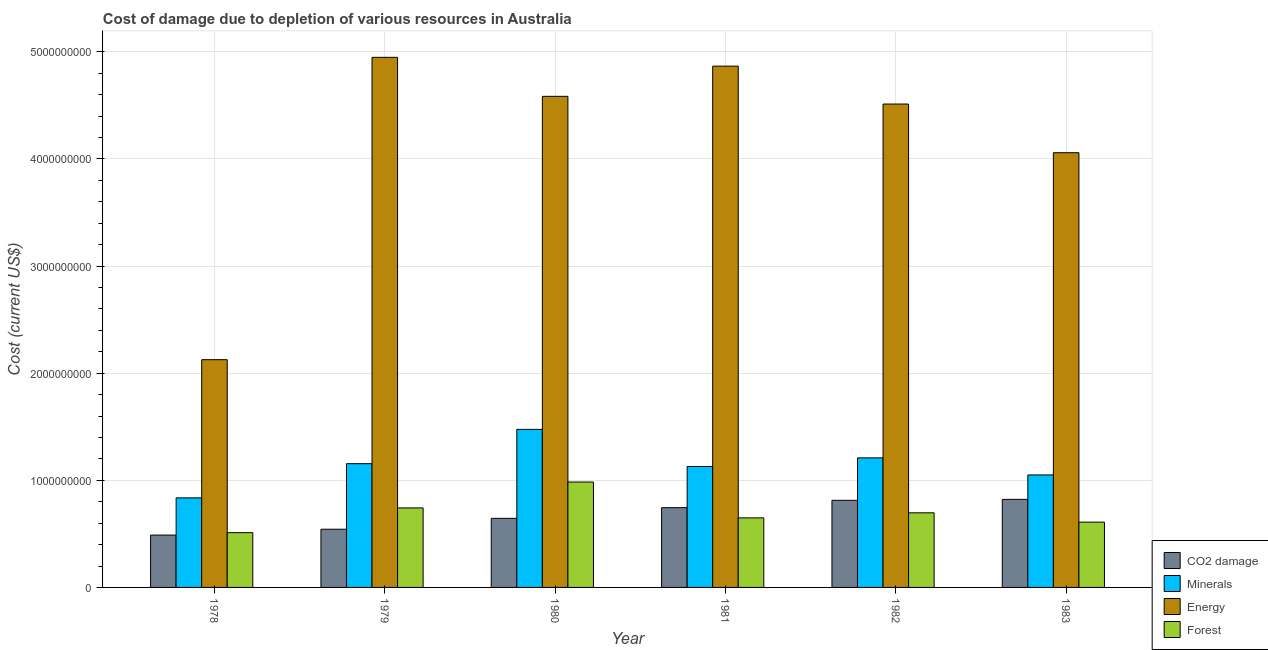How many different coloured bars are there?
Offer a terse response. 4. How many groups of bars are there?
Give a very brief answer. 6. How many bars are there on the 2nd tick from the left?
Your response must be concise. 4. What is the label of the 1st group of bars from the left?
Keep it short and to the point. 1978. What is the cost of damage due to depletion of coal in 1982?
Give a very brief answer. 8.13e+08. Across all years, what is the maximum cost of damage due to depletion of forests?
Offer a terse response. 9.84e+08. Across all years, what is the minimum cost of damage due to depletion of forests?
Make the answer very short. 5.11e+08. In which year was the cost of damage due to depletion of coal minimum?
Offer a terse response. 1978. What is the total cost of damage due to depletion of forests in the graph?
Offer a very short reply. 4.19e+09. What is the difference between the cost of damage due to depletion of minerals in 1979 and that in 1983?
Ensure brevity in your answer.  1.05e+08. What is the difference between the cost of damage due to depletion of minerals in 1979 and the cost of damage due to depletion of forests in 1983?
Provide a succinct answer. 1.05e+08. What is the average cost of damage due to depletion of energy per year?
Your answer should be very brief. 4.18e+09. In how many years, is the cost of damage due to depletion of forests greater than 3400000000 US$?
Your answer should be very brief. 0. What is the ratio of the cost of damage due to depletion of minerals in 1981 to that in 1983?
Provide a succinct answer. 1.08. What is the difference between the highest and the second highest cost of damage due to depletion of coal?
Your answer should be compact. 8.74e+06. What is the difference between the highest and the lowest cost of damage due to depletion of minerals?
Your response must be concise. 6.39e+08. What does the 2nd bar from the left in 1981 represents?
Provide a short and direct response. Minerals. What does the 2nd bar from the right in 1981 represents?
Your response must be concise. Energy. How many bars are there?
Ensure brevity in your answer.  24. Are all the bars in the graph horizontal?
Offer a terse response. No. How many years are there in the graph?
Provide a succinct answer. 6. Where does the legend appear in the graph?
Your answer should be compact. Bottom right. How many legend labels are there?
Ensure brevity in your answer.  4. How are the legend labels stacked?
Ensure brevity in your answer.  Vertical. What is the title of the graph?
Provide a short and direct response. Cost of damage due to depletion of various resources in Australia . What is the label or title of the X-axis?
Make the answer very short. Year. What is the label or title of the Y-axis?
Ensure brevity in your answer.  Cost (current US$). What is the Cost (current US$) of CO2 damage in 1978?
Offer a very short reply. 4.89e+08. What is the Cost (current US$) in Minerals in 1978?
Your answer should be very brief. 8.36e+08. What is the Cost (current US$) in Energy in 1978?
Your answer should be compact. 2.13e+09. What is the Cost (current US$) in Forest in 1978?
Keep it short and to the point. 5.11e+08. What is the Cost (current US$) in CO2 damage in 1979?
Offer a very short reply. 5.43e+08. What is the Cost (current US$) in Minerals in 1979?
Give a very brief answer. 1.16e+09. What is the Cost (current US$) of Energy in 1979?
Ensure brevity in your answer.  4.95e+09. What is the Cost (current US$) in Forest in 1979?
Ensure brevity in your answer.  7.42e+08. What is the Cost (current US$) of CO2 damage in 1980?
Provide a succinct answer. 6.45e+08. What is the Cost (current US$) in Minerals in 1980?
Provide a short and direct response. 1.48e+09. What is the Cost (current US$) in Energy in 1980?
Keep it short and to the point. 4.58e+09. What is the Cost (current US$) in Forest in 1980?
Keep it short and to the point. 9.84e+08. What is the Cost (current US$) of CO2 damage in 1981?
Provide a short and direct response. 7.45e+08. What is the Cost (current US$) in Minerals in 1981?
Give a very brief answer. 1.13e+09. What is the Cost (current US$) in Energy in 1981?
Your answer should be compact. 4.87e+09. What is the Cost (current US$) in Forest in 1981?
Offer a terse response. 6.49e+08. What is the Cost (current US$) in CO2 damage in 1982?
Ensure brevity in your answer.  8.13e+08. What is the Cost (current US$) in Minerals in 1982?
Provide a succinct answer. 1.21e+09. What is the Cost (current US$) in Energy in 1982?
Provide a succinct answer. 4.51e+09. What is the Cost (current US$) in Forest in 1982?
Offer a terse response. 6.96e+08. What is the Cost (current US$) of CO2 damage in 1983?
Your response must be concise. 8.22e+08. What is the Cost (current US$) in Minerals in 1983?
Your answer should be very brief. 1.05e+09. What is the Cost (current US$) of Energy in 1983?
Offer a terse response. 4.06e+09. What is the Cost (current US$) in Forest in 1983?
Your answer should be compact. 6.09e+08. Across all years, what is the maximum Cost (current US$) of CO2 damage?
Offer a very short reply. 8.22e+08. Across all years, what is the maximum Cost (current US$) of Minerals?
Your answer should be compact. 1.48e+09. Across all years, what is the maximum Cost (current US$) in Energy?
Ensure brevity in your answer.  4.95e+09. Across all years, what is the maximum Cost (current US$) in Forest?
Your response must be concise. 9.84e+08. Across all years, what is the minimum Cost (current US$) of CO2 damage?
Give a very brief answer. 4.89e+08. Across all years, what is the minimum Cost (current US$) of Minerals?
Give a very brief answer. 8.36e+08. Across all years, what is the minimum Cost (current US$) of Energy?
Your answer should be compact. 2.13e+09. Across all years, what is the minimum Cost (current US$) of Forest?
Your response must be concise. 5.11e+08. What is the total Cost (current US$) in CO2 damage in the graph?
Offer a very short reply. 4.06e+09. What is the total Cost (current US$) in Minerals in the graph?
Your answer should be very brief. 6.86e+09. What is the total Cost (current US$) of Energy in the graph?
Give a very brief answer. 2.51e+1. What is the total Cost (current US$) in Forest in the graph?
Offer a very short reply. 4.19e+09. What is the difference between the Cost (current US$) in CO2 damage in 1978 and that in 1979?
Ensure brevity in your answer.  -5.46e+07. What is the difference between the Cost (current US$) in Minerals in 1978 and that in 1979?
Your answer should be compact. -3.19e+08. What is the difference between the Cost (current US$) of Energy in 1978 and that in 1979?
Provide a short and direct response. -2.82e+09. What is the difference between the Cost (current US$) in Forest in 1978 and that in 1979?
Ensure brevity in your answer.  -2.31e+08. What is the difference between the Cost (current US$) of CO2 damage in 1978 and that in 1980?
Provide a short and direct response. -1.56e+08. What is the difference between the Cost (current US$) in Minerals in 1978 and that in 1980?
Ensure brevity in your answer.  -6.39e+08. What is the difference between the Cost (current US$) of Energy in 1978 and that in 1980?
Your answer should be compact. -2.46e+09. What is the difference between the Cost (current US$) in Forest in 1978 and that in 1980?
Your response must be concise. -4.72e+08. What is the difference between the Cost (current US$) of CO2 damage in 1978 and that in 1981?
Keep it short and to the point. -2.56e+08. What is the difference between the Cost (current US$) in Minerals in 1978 and that in 1981?
Offer a terse response. -2.93e+08. What is the difference between the Cost (current US$) of Energy in 1978 and that in 1981?
Your response must be concise. -2.74e+09. What is the difference between the Cost (current US$) in Forest in 1978 and that in 1981?
Your answer should be very brief. -1.38e+08. What is the difference between the Cost (current US$) in CO2 damage in 1978 and that in 1982?
Offer a very short reply. -3.25e+08. What is the difference between the Cost (current US$) in Minerals in 1978 and that in 1982?
Your answer should be compact. -3.73e+08. What is the difference between the Cost (current US$) of Energy in 1978 and that in 1982?
Your answer should be very brief. -2.39e+09. What is the difference between the Cost (current US$) of Forest in 1978 and that in 1982?
Offer a very short reply. -1.85e+08. What is the difference between the Cost (current US$) in CO2 damage in 1978 and that in 1983?
Make the answer very short. -3.33e+08. What is the difference between the Cost (current US$) in Minerals in 1978 and that in 1983?
Provide a succinct answer. -2.14e+08. What is the difference between the Cost (current US$) of Energy in 1978 and that in 1983?
Provide a succinct answer. -1.93e+09. What is the difference between the Cost (current US$) of Forest in 1978 and that in 1983?
Provide a short and direct response. -9.81e+07. What is the difference between the Cost (current US$) of CO2 damage in 1979 and that in 1980?
Your answer should be very brief. -1.02e+08. What is the difference between the Cost (current US$) of Minerals in 1979 and that in 1980?
Your answer should be compact. -3.20e+08. What is the difference between the Cost (current US$) of Energy in 1979 and that in 1980?
Offer a terse response. 3.64e+08. What is the difference between the Cost (current US$) in Forest in 1979 and that in 1980?
Provide a succinct answer. -2.42e+08. What is the difference between the Cost (current US$) in CO2 damage in 1979 and that in 1981?
Your response must be concise. -2.01e+08. What is the difference between the Cost (current US$) in Minerals in 1979 and that in 1981?
Offer a very short reply. 2.62e+07. What is the difference between the Cost (current US$) of Energy in 1979 and that in 1981?
Provide a succinct answer. 8.22e+07. What is the difference between the Cost (current US$) of Forest in 1979 and that in 1981?
Offer a very short reply. 9.31e+07. What is the difference between the Cost (current US$) of CO2 damage in 1979 and that in 1982?
Provide a succinct answer. -2.70e+08. What is the difference between the Cost (current US$) of Minerals in 1979 and that in 1982?
Your answer should be very brief. -5.43e+07. What is the difference between the Cost (current US$) in Energy in 1979 and that in 1982?
Your answer should be very brief. 4.36e+08. What is the difference between the Cost (current US$) of Forest in 1979 and that in 1982?
Give a very brief answer. 4.57e+07. What is the difference between the Cost (current US$) in CO2 damage in 1979 and that in 1983?
Keep it short and to the point. -2.79e+08. What is the difference between the Cost (current US$) of Minerals in 1979 and that in 1983?
Offer a terse response. 1.05e+08. What is the difference between the Cost (current US$) in Energy in 1979 and that in 1983?
Make the answer very short. 8.90e+08. What is the difference between the Cost (current US$) in Forest in 1979 and that in 1983?
Your answer should be compact. 1.33e+08. What is the difference between the Cost (current US$) in CO2 damage in 1980 and that in 1981?
Make the answer very short. -9.96e+07. What is the difference between the Cost (current US$) in Minerals in 1980 and that in 1981?
Provide a succinct answer. 3.46e+08. What is the difference between the Cost (current US$) of Energy in 1980 and that in 1981?
Give a very brief answer. -2.82e+08. What is the difference between the Cost (current US$) of Forest in 1980 and that in 1981?
Provide a short and direct response. 3.35e+08. What is the difference between the Cost (current US$) of CO2 damage in 1980 and that in 1982?
Give a very brief answer. -1.68e+08. What is the difference between the Cost (current US$) in Minerals in 1980 and that in 1982?
Provide a short and direct response. 2.66e+08. What is the difference between the Cost (current US$) in Energy in 1980 and that in 1982?
Offer a terse response. 7.18e+07. What is the difference between the Cost (current US$) of Forest in 1980 and that in 1982?
Make the answer very short. 2.87e+08. What is the difference between the Cost (current US$) in CO2 damage in 1980 and that in 1983?
Provide a succinct answer. -1.77e+08. What is the difference between the Cost (current US$) of Minerals in 1980 and that in 1983?
Keep it short and to the point. 4.25e+08. What is the difference between the Cost (current US$) in Energy in 1980 and that in 1983?
Provide a succinct answer. 5.26e+08. What is the difference between the Cost (current US$) of Forest in 1980 and that in 1983?
Make the answer very short. 3.74e+08. What is the difference between the Cost (current US$) in CO2 damage in 1981 and that in 1982?
Your answer should be compact. -6.85e+07. What is the difference between the Cost (current US$) in Minerals in 1981 and that in 1982?
Your answer should be compact. -8.05e+07. What is the difference between the Cost (current US$) in Energy in 1981 and that in 1982?
Provide a short and direct response. 3.54e+08. What is the difference between the Cost (current US$) of Forest in 1981 and that in 1982?
Give a very brief answer. -4.74e+07. What is the difference between the Cost (current US$) of CO2 damage in 1981 and that in 1983?
Provide a short and direct response. -7.73e+07. What is the difference between the Cost (current US$) of Minerals in 1981 and that in 1983?
Provide a short and direct response. 7.89e+07. What is the difference between the Cost (current US$) in Energy in 1981 and that in 1983?
Give a very brief answer. 8.08e+08. What is the difference between the Cost (current US$) of Forest in 1981 and that in 1983?
Provide a succinct answer. 3.97e+07. What is the difference between the Cost (current US$) of CO2 damage in 1982 and that in 1983?
Make the answer very short. -8.74e+06. What is the difference between the Cost (current US$) of Minerals in 1982 and that in 1983?
Your answer should be compact. 1.59e+08. What is the difference between the Cost (current US$) of Energy in 1982 and that in 1983?
Provide a succinct answer. 4.54e+08. What is the difference between the Cost (current US$) of Forest in 1982 and that in 1983?
Ensure brevity in your answer.  8.70e+07. What is the difference between the Cost (current US$) in CO2 damage in 1978 and the Cost (current US$) in Minerals in 1979?
Ensure brevity in your answer.  -6.67e+08. What is the difference between the Cost (current US$) in CO2 damage in 1978 and the Cost (current US$) in Energy in 1979?
Make the answer very short. -4.46e+09. What is the difference between the Cost (current US$) in CO2 damage in 1978 and the Cost (current US$) in Forest in 1979?
Offer a very short reply. -2.54e+08. What is the difference between the Cost (current US$) in Minerals in 1978 and the Cost (current US$) in Energy in 1979?
Provide a succinct answer. -4.11e+09. What is the difference between the Cost (current US$) in Minerals in 1978 and the Cost (current US$) in Forest in 1979?
Offer a very short reply. 9.38e+07. What is the difference between the Cost (current US$) in Energy in 1978 and the Cost (current US$) in Forest in 1979?
Your answer should be compact. 1.38e+09. What is the difference between the Cost (current US$) in CO2 damage in 1978 and the Cost (current US$) in Minerals in 1980?
Offer a terse response. -9.87e+08. What is the difference between the Cost (current US$) of CO2 damage in 1978 and the Cost (current US$) of Energy in 1980?
Your answer should be compact. -4.10e+09. What is the difference between the Cost (current US$) of CO2 damage in 1978 and the Cost (current US$) of Forest in 1980?
Make the answer very short. -4.95e+08. What is the difference between the Cost (current US$) of Minerals in 1978 and the Cost (current US$) of Energy in 1980?
Your answer should be compact. -3.75e+09. What is the difference between the Cost (current US$) in Minerals in 1978 and the Cost (current US$) in Forest in 1980?
Keep it short and to the point. -1.48e+08. What is the difference between the Cost (current US$) in Energy in 1978 and the Cost (current US$) in Forest in 1980?
Provide a short and direct response. 1.14e+09. What is the difference between the Cost (current US$) in CO2 damage in 1978 and the Cost (current US$) in Minerals in 1981?
Offer a very short reply. -6.40e+08. What is the difference between the Cost (current US$) in CO2 damage in 1978 and the Cost (current US$) in Energy in 1981?
Ensure brevity in your answer.  -4.38e+09. What is the difference between the Cost (current US$) of CO2 damage in 1978 and the Cost (current US$) of Forest in 1981?
Offer a very short reply. -1.61e+08. What is the difference between the Cost (current US$) in Minerals in 1978 and the Cost (current US$) in Energy in 1981?
Your answer should be very brief. -4.03e+09. What is the difference between the Cost (current US$) of Minerals in 1978 and the Cost (current US$) of Forest in 1981?
Make the answer very short. 1.87e+08. What is the difference between the Cost (current US$) of Energy in 1978 and the Cost (current US$) of Forest in 1981?
Provide a succinct answer. 1.48e+09. What is the difference between the Cost (current US$) in CO2 damage in 1978 and the Cost (current US$) in Minerals in 1982?
Give a very brief answer. -7.21e+08. What is the difference between the Cost (current US$) of CO2 damage in 1978 and the Cost (current US$) of Energy in 1982?
Provide a succinct answer. -4.02e+09. What is the difference between the Cost (current US$) in CO2 damage in 1978 and the Cost (current US$) in Forest in 1982?
Your answer should be very brief. -2.08e+08. What is the difference between the Cost (current US$) of Minerals in 1978 and the Cost (current US$) of Energy in 1982?
Offer a very short reply. -3.68e+09. What is the difference between the Cost (current US$) of Minerals in 1978 and the Cost (current US$) of Forest in 1982?
Keep it short and to the point. 1.40e+08. What is the difference between the Cost (current US$) in Energy in 1978 and the Cost (current US$) in Forest in 1982?
Offer a terse response. 1.43e+09. What is the difference between the Cost (current US$) in CO2 damage in 1978 and the Cost (current US$) in Minerals in 1983?
Make the answer very short. -5.61e+08. What is the difference between the Cost (current US$) of CO2 damage in 1978 and the Cost (current US$) of Energy in 1983?
Ensure brevity in your answer.  -3.57e+09. What is the difference between the Cost (current US$) in CO2 damage in 1978 and the Cost (current US$) in Forest in 1983?
Ensure brevity in your answer.  -1.21e+08. What is the difference between the Cost (current US$) in Minerals in 1978 and the Cost (current US$) in Energy in 1983?
Provide a succinct answer. -3.22e+09. What is the difference between the Cost (current US$) in Minerals in 1978 and the Cost (current US$) in Forest in 1983?
Your answer should be compact. 2.27e+08. What is the difference between the Cost (current US$) in Energy in 1978 and the Cost (current US$) in Forest in 1983?
Ensure brevity in your answer.  1.52e+09. What is the difference between the Cost (current US$) of CO2 damage in 1979 and the Cost (current US$) of Minerals in 1980?
Offer a very short reply. -9.32e+08. What is the difference between the Cost (current US$) of CO2 damage in 1979 and the Cost (current US$) of Energy in 1980?
Your answer should be compact. -4.04e+09. What is the difference between the Cost (current US$) of CO2 damage in 1979 and the Cost (current US$) of Forest in 1980?
Your response must be concise. -4.40e+08. What is the difference between the Cost (current US$) of Minerals in 1979 and the Cost (current US$) of Energy in 1980?
Offer a very short reply. -3.43e+09. What is the difference between the Cost (current US$) of Minerals in 1979 and the Cost (current US$) of Forest in 1980?
Make the answer very short. 1.71e+08. What is the difference between the Cost (current US$) of Energy in 1979 and the Cost (current US$) of Forest in 1980?
Make the answer very short. 3.96e+09. What is the difference between the Cost (current US$) of CO2 damage in 1979 and the Cost (current US$) of Minerals in 1981?
Offer a very short reply. -5.86e+08. What is the difference between the Cost (current US$) in CO2 damage in 1979 and the Cost (current US$) in Energy in 1981?
Offer a terse response. -4.32e+09. What is the difference between the Cost (current US$) in CO2 damage in 1979 and the Cost (current US$) in Forest in 1981?
Your answer should be very brief. -1.06e+08. What is the difference between the Cost (current US$) of Minerals in 1979 and the Cost (current US$) of Energy in 1981?
Your response must be concise. -3.71e+09. What is the difference between the Cost (current US$) in Minerals in 1979 and the Cost (current US$) in Forest in 1981?
Make the answer very short. 5.06e+08. What is the difference between the Cost (current US$) of Energy in 1979 and the Cost (current US$) of Forest in 1981?
Give a very brief answer. 4.30e+09. What is the difference between the Cost (current US$) of CO2 damage in 1979 and the Cost (current US$) of Minerals in 1982?
Provide a short and direct response. -6.66e+08. What is the difference between the Cost (current US$) in CO2 damage in 1979 and the Cost (current US$) in Energy in 1982?
Your answer should be very brief. -3.97e+09. What is the difference between the Cost (current US$) of CO2 damage in 1979 and the Cost (current US$) of Forest in 1982?
Offer a terse response. -1.53e+08. What is the difference between the Cost (current US$) in Minerals in 1979 and the Cost (current US$) in Energy in 1982?
Give a very brief answer. -3.36e+09. What is the difference between the Cost (current US$) in Minerals in 1979 and the Cost (current US$) in Forest in 1982?
Keep it short and to the point. 4.59e+08. What is the difference between the Cost (current US$) of Energy in 1979 and the Cost (current US$) of Forest in 1982?
Your response must be concise. 4.25e+09. What is the difference between the Cost (current US$) of CO2 damage in 1979 and the Cost (current US$) of Minerals in 1983?
Provide a succinct answer. -5.07e+08. What is the difference between the Cost (current US$) of CO2 damage in 1979 and the Cost (current US$) of Energy in 1983?
Provide a succinct answer. -3.51e+09. What is the difference between the Cost (current US$) in CO2 damage in 1979 and the Cost (current US$) in Forest in 1983?
Offer a terse response. -6.62e+07. What is the difference between the Cost (current US$) of Minerals in 1979 and the Cost (current US$) of Energy in 1983?
Ensure brevity in your answer.  -2.90e+09. What is the difference between the Cost (current US$) of Minerals in 1979 and the Cost (current US$) of Forest in 1983?
Ensure brevity in your answer.  5.46e+08. What is the difference between the Cost (current US$) in Energy in 1979 and the Cost (current US$) in Forest in 1983?
Your response must be concise. 4.34e+09. What is the difference between the Cost (current US$) of CO2 damage in 1980 and the Cost (current US$) of Minerals in 1981?
Provide a succinct answer. -4.84e+08. What is the difference between the Cost (current US$) in CO2 damage in 1980 and the Cost (current US$) in Energy in 1981?
Make the answer very short. -4.22e+09. What is the difference between the Cost (current US$) in CO2 damage in 1980 and the Cost (current US$) in Forest in 1981?
Provide a succinct answer. -4.12e+06. What is the difference between the Cost (current US$) in Minerals in 1980 and the Cost (current US$) in Energy in 1981?
Ensure brevity in your answer.  -3.39e+09. What is the difference between the Cost (current US$) of Minerals in 1980 and the Cost (current US$) of Forest in 1981?
Ensure brevity in your answer.  8.26e+08. What is the difference between the Cost (current US$) in Energy in 1980 and the Cost (current US$) in Forest in 1981?
Your answer should be very brief. 3.94e+09. What is the difference between the Cost (current US$) in CO2 damage in 1980 and the Cost (current US$) in Minerals in 1982?
Offer a very short reply. -5.64e+08. What is the difference between the Cost (current US$) in CO2 damage in 1980 and the Cost (current US$) in Energy in 1982?
Your response must be concise. -3.87e+09. What is the difference between the Cost (current US$) in CO2 damage in 1980 and the Cost (current US$) in Forest in 1982?
Offer a terse response. -5.15e+07. What is the difference between the Cost (current US$) in Minerals in 1980 and the Cost (current US$) in Energy in 1982?
Keep it short and to the point. -3.04e+09. What is the difference between the Cost (current US$) in Minerals in 1980 and the Cost (current US$) in Forest in 1982?
Your answer should be compact. 7.79e+08. What is the difference between the Cost (current US$) in Energy in 1980 and the Cost (current US$) in Forest in 1982?
Give a very brief answer. 3.89e+09. What is the difference between the Cost (current US$) in CO2 damage in 1980 and the Cost (current US$) in Minerals in 1983?
Your answer should be very brief. -4.05e+08. What is the difference between the Cost (current US$) of CO2 damage in 1980 and the Cost (current US$) of Energy in 1983?
Offer a terse response. -3.41e+09. What is the difference between the Cost (current US$) in CO2 damage in 1980 and the Cost (current US$) in Forest in 1983?
Offer a very short reply. 3.55e+07. What is the difference between the Cost (current US$) in Minerals in 1980 and the Cost (current US$) in Energy in 1983?
Offer a very short reply. -2.58e+09. What is the difference between the Cost (current US$) in Minerals in 1980 and the Cost (current US$) in Forest in 1983?
Provide a short and direct response. 8.66e+08. What is the difference between the Cost (current US$) of Energy in 1980 and the Cost (current US$) of Forest in 1983?
Your answer should be very brief. 3.97e+09. What is the difference between the Cost (current US$) of CO2 damage in 1981 and the Cost (current US$) of Minerals in 1982?
Provide a succinct answer. -4.65e+08. What is the difference between the Cost (current US$) in CO2 damage in 1981 and the Cost (current US$) in Energy in 1982?
Your response must be concise. -3.77e+09. What is the difference between the Cost (current US$) in CO2 damage in 1981 and the Cost (current US$) in Forest in 1982?
Offer a terse response. 4.81e+07. What is the difference between the Cost (current US$) of Minerals in 1981 and the Cost (current US$) of Energy in 1982?
Ensure brevity in your answer.  -3.38e+09. What is the difference between the Cost (current US$) of Minerals in 1981 and the Cost (current US$) of Forest in 1982?
Your answer should be very brief. 4.32e+08. What is the difference between the Cost (current US$) of Energy in 1981 and the Cost (current US$) of Forest in 1982?
Provide a short and direct response. 4.17e+09. What is the difference between the Cost (current US$) of CO2 damage in 1981 and the Cost (current US$) of Minerals in 1983?
Your answer should be compact. -3.05e+08. What is the difference between the Cost (current US$) of CO2 damage in 1981 and the Cost (current US$) of Energy in 1983?
Your response must be concise. -3.31e+09. What is the difference between the Cost (current US$) in CO2 damage in 1981 and the Cost (current US$) in Forest in 1983?
Give a very brief answer. 1.35e+08. What is the difference between the Cost (current US$) in Minerals in 1981 and the Cost (current US$) in Energy in 1983?
Provide a succinct answer. -2.93e+09. What is the difference between the Cost (current US$) of Minerals in 1981 and the Cost (current US$) of Forest in 1983?
Offer a terse response. 5.20e+08. What is the difference between the Cost (current US$) in Energy in 1981 and the Cost (current US$) in Forest in 1983?
Your answer should be compact. 4.26e+09. What is the difference between the Cost (current US$) of CO2 damage in 1982 and the Cost (current US$) of Minerals in 1983?
Provide a succinct answer. -2.37e+08. What is the difference between the Cost (current US$) in CO2 damage in 1982 and the Cost (current US$) in Energy in 1983?
Offer a terse response. -3.24e+09. What is the difference between the Cost (current US$) of CO2 damage in 1982 and the Cost (current US$) of Forest in 1983?
Give a very brief answer. 2.04e+08. What is the difference between the Cost (current US$) in Minerals in 1982 and the Cost (current US$) in Energy in 1983?
Make the answer very short. -2.85e+09. What is the difference between the Cost (current US$) in Minerals in 1982 and the Cost (current US$) in Forest in 1983?
Keep it short and to the point. 6.00e+08. What is the difference between the Cost (current US$) in Energy in 1982 and the Cost (current US$) in Forest in 1983?
Ensure brevity in your answer.  3.90e+09. What is the average Cost (current US$) of CO2 damage per year?
Give a very brief answer. 6.76e+08. What is the average Cost (current US$) in Minerals per year?
Your response must be concise. 1.14e+09. What is the average Cost (current US$) in Energy per year?
Keep it short and to the point. 4.18e+09. What is the average Cost (current US$) in Forest per year?
Provide a succinct answer. 6.99e+08. In the year 1978, what is the difference between the Cost (current US$) in CO2 damage and Cost (current US$) in Minerals?
Keep it short and to the point. -3.47e+08. In the year 1978, what is the difference between the Cost (current US$) of CO2 damage and Cost (current US$) of Energy?
Ensure brevity in your answer.  -1.64e+09. In the year 1978, what is the difference between the Cost (current US$) in CO2 damage and Cost (current US$) in Forest?
Keep it short and to the point. -2.27e+07. In the year 1978, what is the difference between the Cost (current US$) of Minerals and Cost (current US$) of Energy?
Offer a terse response. -1.29e+09. In the year 1978, what is the difference between the Cost (current US$) of Minerals and Cost (current US$) of Forest?
Provide a short and direct response. 3.25e+08. In the year 1978, what is the difference between the Cost (current US$) in Energy and Cost (current US$) in Forest?
Ensure brevity in your answer.  1.61e+09. In the year 1979, what is the difference between the Cost (current US$) of CO2 damage and Cost (current US$) of Minerals?
Make the answer very short. -6.12e+08. In the year 1979, what is the difference between the Cost (current US$) in CO2 damage and Cost (current US$) in Energy?
Offer a very short reply. -4.41e+09. In the year 1979, what is the difference between the Cost (current US$) of CO2 damage and Cost (current US$) of Forest?
Give a very brief answer. -1.99e+08. In the year 1979, what is the difference between the Cost (current US$) of Minerals and Cost (current US$) of Energy?
Provide a short and direct response. -3.79e+09. In the year 1979, what is the difference between the Cost (current US$) in Minerals and Cost (current US$) in Forest?
Offer a terse response. 4.13e+08. In the year 1979, what is the difference between the Cost (current US$) in Energy and Cost (current US$) in Forest?
Give a very brief answer. 4.21e+09. In the year 1980, what is the difference between the Cost (current US$) in CO2 damage and Cost (current US$) in Minerals?
Provide a succinct answer. -8.30e+08. In the year 1980, what is the difference between the Cost (current US$) in CO2 damage and Cost (current US$) in Energy?
Your response must be concise. -3.94e+09. In the year 1980, what is the difference between the Cost (current US$) in CO2 damage and Cost (current US$) in Forest?
Provide a succinct answer. -3.39e+08. In the year 1980, what is the difference between the Cost (current US$) of Minerals and Cost (current US$) of Energy?
Provide a short and direct response. -3.11e+09. In the year 1980, what is the difference between the Cost (current US$) in Minerals and Cost (current US$) in Forest?
Your response must be concise. 4.92e+08. In the year 1980, what is the difference between the Cost (current US$) of Energy and Cost (current US$) of Forest?
Provide a succinct answer. 3.60e+09. In the year 1981, what is the difference between the Cost (current US$) of CO2 damage and Cost (current US$) of Minerals?
Offer a very short reply. -3.84e+08. In the year 1981, what is the difference between the Cost (current US$) in CO2 damage and Cost (current US$) in Energy?
Provide a short and direct response. -4.12e+09. In the year 1981, what is the difference between the Cost (current US$) in CO2 damage and Cost (current US$) in Forest?
Your answer should be compact. 9.55e+07. In the year 1981, what is the difference between the Cost (current US$) of Minerals and Cost (current US$) of Energy?
Provide a short and direct response. -3.74e+09. In the year 1981, what is the difference between the Cost (current US$) in Minerals and Cost (current US$) in Forest?
Your answer should be compact. 4.80e+08. In the year 1981, what is the difference between the Cost (current US$) in Energy and Cost (current US$) in Forest?
Provide a short and direct response. 4.22e+09. In the year 1982, what is the difference between the Cost (current US$) in CO2 damage and Cost (current US$) in Minerals?
Make the answer very short. -3.96e+08. In the year 1982, what is the difference between the Cost (current US$) in CO2 damage and Cost (current US$) in Energy?
Provide a short and direct response. -3.70e+09. In the year 1982, what is the difference between the Cost (current US$) of CO2 damage and Cost (current US$) of Forest?
Keep it short and to the point. 1.17e+08. In the year 1982, what is the difference between the Cost (current US$) of Minerals and Cost (current US$) of Energy?
Make the answer very short. -3.30e+09. In the year 1982, what is the difference between the Cost (current US$) of Minerals and Cost (current US$) of Forest?
Keep it short and to the point. 5.13e+08. In the year 1982, what is the difference between the Cost (current US$) of Energy and Cost (current US$) of Forest?
Provide a short and direct response. 3.82e+09. In the year 1983, what is the difference between the Cost (current US$) of CO2 damage and Cost (current US$) of Minerals?
Your answer should be compact. -2.28e+08. In the year 1983, what is the difference between the Cost (current US$) in CO2 damage and Cost (current US$) in Energy?
Your response must be concise. -3.24e+09. In the year 1983, what is the difference between the Cost (current US$) in CO2 damage and Cost (current US$) in Forest?
Keep it short and to the point. 2.12e+08. In the year 1983, what is the difference between the Cost (current US$) of Minerals and Cost (current US$) of Energy?
Your answer should be very brief. -3.01e+09. In the year 1983, what is the difference between the Cost (current US$) in Minerals and Cost (current US$) in Forest?
Keep it short and to the point. 4.41e+08. In the year 1983, what is the difference between the Cost (current US$) in Energy and Cost (current US$) in Forest?
Give a very brief answer. 3.45e+09. What is the ratio of the Cost (current US$) in CO2 damage in 1978 to that in 1979?
Offer a terse response. 0.9. What is the ratio of the Cost (current US$) in Minerals in 1978 to that in 1979?
Your answer should be compact. 0.72. What is the ratio of the Cost (current US$) in Energy in 1978 to that in 1979?
Provide a short and direct response. 0.43. What is the ratio of the Cost (current US$) in Forest in 1978 to that in 1979?
Your response must be concise. 0.69. What is the ratio of the Cost (current US$) in CO2 damage in 1978 to that in 1980?
Keep it short and to the point. 0.76. What is the ratio of the Cost (current US$) in Minerals in 1978 to that in 1980?
Your answer should be very brief. 0.57. What is the ratio of the Cost (current US$) of Energy in 1978 to that in 1980?
Provide a short and direct response. 0.46. What is the ratio of the Cost (current US$) of Forest in 1978 to that in 1980?
Keep it short and to the point. 0.52. What is the ratio of the Cost (current US$) in CO2 damage in 1978 to that in 1981?
Offer a very short reply. 0.66. What is the ratio of the Cost (current US$) of Minerals in 1978 to that in 1981?
Ensure brevity in your answer.  0.74. What is the ratio of the Cost (current US$) of Energy in 1978 to that in 1981?
Your answer should be compact. 0.44. What is the ratio of the Cost (current US$) of Forest in 1978 to that in 1981?
Provide a succinct answer. 0.79. What is the ratio of the Cost (current US$) of CO2 damage in 1978 to that in 1982?
Provide a succinct answer. 0.6. What is the ratio of the Cost (current US$) of Minerals in 1978 to that in 1982?
Offer a terse response. 0.69. What is the ratio of the Cost (current US$) of Energy in 1978 to that in 1982?
Keep it short and to the point. 0.47. What is the ratio of the Cost (current US$) of Forest in 1978 to that in 1982?
Provide a short and direct response. 0.73. What is the ratio of the Cost (current US$) in CO2 damage in 1978 to that in 1983?
Ensure brevity in your answer.  0.59. What is the ratio of the Cost (current US$) in Minerals in 1978 to that in 1983?
Provide a short and direct response. 0.8. What is the ratio of the Cost (current US$) in Energy in 1978 to that in 1983?
Your response must be concise. 0.52. What is the ratio of the Cost (current US$) of Forest in 1978 to that in 1983?
Offer a very short reply. 0.84. What is the ratio of the Cost (current US$) of CO2 damage in 1979 to that in 1980?
Offer a terse response. 0.84. What is the ratio of the Cost (current US$) in Minerals in 1979 to that in 1980?
Your response must be concise. 0.78. What is the ratio of the Cost (current US$) in Energy in 1979 to that in 1980?
Give a very brief answer. 1.08. What is the ratio of the Cost (current US$) of Forest in 1979 to that in 1980?
Provide a succinct answer. 0.75. What is the ratio of the Cost (current US$) of CO2 damage in 1979 to that in 1981?
Offer a terse response. 0.73. What is the ratio of the Cost (current US$) of Minerals in 1979 to that in 1981?
Provide a short and direct response. 1.02. What is the ratio of the Cost (current US$) of Energy in 1979 to that in 1981?
Ensure brevity in your answer.  1.02. What is the ratio of the Cost (current US$) of Forest in 1979 to that in 1981?
Offer a very short reply. 1.14. What is the ratio of the Cost (current US$) of CO2 damage in 1979 to that in 1982?
Offer a very short reply. 0.67. What is the ratio of the Cost (current US$) of Minerals in 1979 to that in 1982?
Make the answer very short. 0.96. What is the ratio of the Cost (current US$) in Energy in 1979 to that in 1982?
Ensure brevity in your answer.  1.1. What is the ratio of the Cost (current US$) in Forest in 1979 to that in 1982?
Offer a very short reply. 1.07. What is the ratio of the Cost (current US$) in CO2 damage in 1979 to that in 1983?
Your response must be concise. 0.66. What is the ratio of the Cost (current US$) of Minerals in 1979 to that in 1983?
Your answer should be very brief. 1.1. What is the ratio of the Cost (current US$) in Energy in 1979 to that in 1983?
Give a very brief answer. 1.22. What is the ratio of the Cost (current US$) of Forest in 1979 to that in 1983?
Offer a terse response. 1.22. What is the ratio of the Cost (current US$) in CO2 damage in 1980 to that in 1981?
Offer a very short reply. 0.87. What is the ratio of the Cost (current US$) of Minerals in 1980 to that in 1981?
Your answer should be compact. 1.31. What is the ratio of the Cost (current US$) in Energy in 1980 to that in 1981?
Keep it short and to the point. 0.94. What is the ratio of the Cost (current US$) of Forest in 1980 to that in 1981?
Give a very brief answer. 1.52. What is the ratio of the Cost (current US$) in CO2 damage in 1980 to that in 1982?
Your response must be concise. 0.79. What is the ratio of the Cost (current US$) of Minerals in 1980 to that in 1982?
Give a very brief answer. 1.22. What is the ratio of the Cost (current US$) in Energy in 1980 to that in 1982?
Your response must be concise. 1.02. What is the ratio of the Cost (current US$) in Forest in 1980 to that in 1982?
Your answer should be very brief. 1.41. What is the ratio of the Cost (current US$) of CO2 damage in 1980 to that in 1983?
Your answer should be very brief. 0.78. What is the ratio of the Cost (current US$) of Minerals in 1980 to that in 1983?
Ensure brevity in your answer.  1.41. What is the ratio of the Cost (current US$) of Energy in 1980 to that in 1983?
Offer a terse response. 1.13. What is the ratio of the Cost (current US$) of Forest in 1980 to that in 1983?
Make the answer very short. 1.61. What is the ratio of the Cost (current US$) in CO2 damage in 1981 to that in 1982?
Make the answer very short. 0.92. What is the ratio of the Cost (current US$) of Minerals in 1981 to that in 1982?
Provide a short and direct response. 0.93. What is the ratio of the Cost (current US$) in Energy in 1981 to that in 1982?
Provide a succinct answer. 1.08. What is the ratio of the Cost (current US$) in Forest in 1981 to that in 1982?
Provide a succinct answer. 0.93. What is the ratio of the Cost (current US$) of CO2 damage in 1981 to that in 1983?
Make the answer very short. 0.91. What is the ratio of the Cost (current US$) of Minerals in 1981 to that in 1983?
Your response must be concise. 1.08. What is the ratio of the Cost (current US$) of Energy in 1981 to that in 1983?
Give a very brief answer. 1.2. What is the ratio of the Cost (current US$) of Forest in 1981 to that in 1983?
Offer a terse response. 1.07. What is the ratio of the Cost (current US$) in CO2 damage in 1982 to that in 1983?
Give a very brief answer. 0.99. What is the ratio of the Cost (current US$) of Minerals in 1982 to that in 1983?
Provide a short and direct response. 1.15. What is the ratio of the Cost (current US$) of Energy in 1982 to that in 1983?
Keep it short and to the point. 1.11. What is the ratio of the Cost (current US$) in Forest in 1982 to that in 1983?
Offer a terse response. 1.14. What is the difference between the highest and the second highest Cost (current US$) of CO2 damage?
Give a very brief answer. 8.74e+06. What is the difference between the highest and the second highest Cost (current US$) of Minerals?
Provide a short and direct response. 2.66e+08. What is the difference between the highest and the second highest Cost (current US$) in Energy?
Give a very brief answer. 8.22e+07. What is the difference between the highest and the second highest Cost (current US$) in Forest?
Offer a very short reply. 2.42e+08. What is the difference between the highest and the lowest Cost (current US$) in CO2 damage?
Your answer should be very brief. 3.33e+08. What is the difference between the highest and the lowest Cost (current US$) of Minerals?
Keep it short and to the point. 6.39e+08. What is the difference between the highest and the lowest Cost (current US$) in Energy?
Provide a short and direct response. 2.82e+09. What is the difference between the highest and the lowest Cost (current US$) in Forest?
Keep it short and to the point. 4.72e+08. 